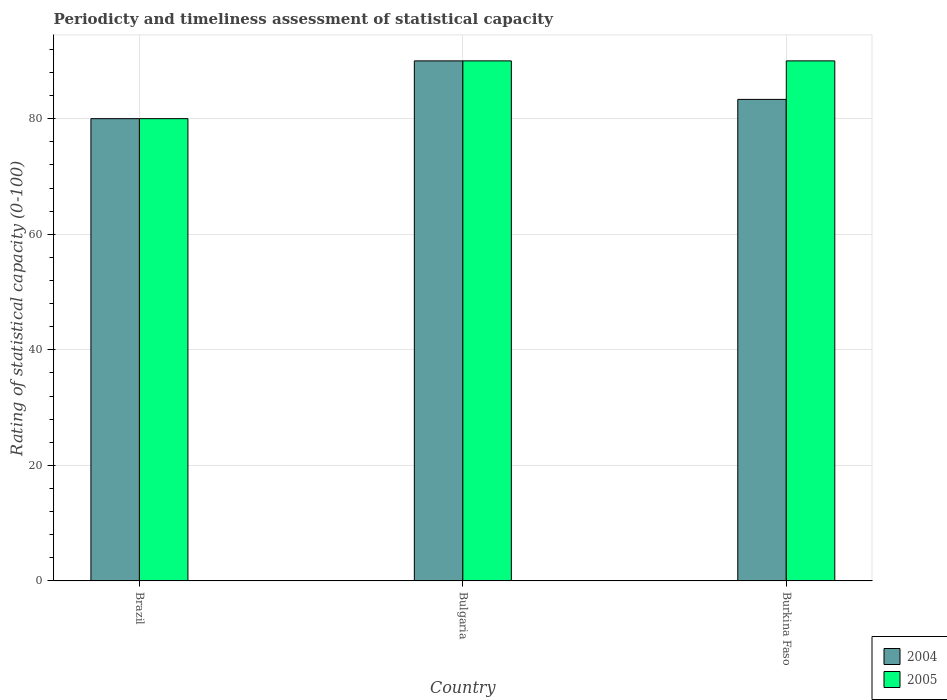How many different coloured bars are there?
Offer a terse response. 2. Are the number of bars on each tick of the X-axis equal?
Provide a short and direct response. Yes. How many bars are there on the 1st tick from the left?
Provide a succinct answer. 2. How many bars are there on the 3rd tick from the right?
Ensure brevity in your answer.  2. What is the label of the 2nd group of bars from the left?
Ensure brevity in your answer.  Bulgaria. In how many cases, is the number of bars for a given country not equal to the number of legend labels?
Provide a short and direct response. 0. In which country was the rating of statistical capacity in 2004 maximum?
Your response must be concise. Bulgaria. In which country was the rating of statistical capacity in 2005 minimum?
Provide a short and direct response. Brazil. What is the total rating of statistical capacity in 2005 in the graph?
Your response must be concise. 260. What is the difference between the rating of statistical capacity in 2004 in Burkina Faso and the rating of statistical capacity in 2005 in Bulgaria?
Ensure brevity in your answer.  -6.67. What is the average rating of statistical capacity in 2005 per country?
Keep it short and to the point. 86.67. What is the difference between the rating of statistical capacity of/in 2004 and rating of statistical capacity of/in 2005 in Burkina Faso?
Keep it short and to the point. -6.67. What is the ratio of the rating of statistical capacity in 2004 in Brazil to that in Bulgaria?
Keep it short and to the point. 0.89. Is the rating of statistical capacity in 2004 in Bulgaria less than that in Burkina Faso?
Make the answer very short. No. Is the difference between the rating of statistical capacity in 2004 in Bulgaria and Burkina Faso greater than the difference between the rating of statistical capacity in 2005 in Bulgaria and Burkina Faso?
Your response must be concise. Yes. What is the difference between the highest and the lowest rating of statistical capacity in 2004?
Your answer should be compact. 10. Is the sum of the rating of statistical capacity in 2004 in Bulgaria and Burkina Faso greater than the maximum rating of statistical capacity in 2005 across all countries?
Make the answer very short. Yes. What does the 2nd bar from the left in Bulgaria represents?
Your answer should be very brief. 2005. How many bars are there?
Offer a terse response. 6. What is the difference between two consecutive major ticks on the Y-axis?
Your answer should be compact. 20. Are the values on the major ticks of Y-axis written in scientific E-notation?
Ensure brevity in your answer.  No. Does the graph contain any zero values?
Offer a very short reply. No. Does the graph contain grids?
Your answer should be very brief. Yes. How many legend labels are there?
Your answer should be compact. 2. What is the title of the graph?
Ensure brevity in your answer.  Periodicty and timeliness assessment of statistical capacity. What is the label or title of the X-axis?
Offer a very short reply. Country. What is the label or title of the Y-axis?
Provide a short and direct response. Rating of statistical capacity (0-100). What is the Rating of statistical capacity (0-100) of 2005 in Brazil?
Give a very brief answer. 80. What is the Rating of statistical capacity (0-100) of 2004 in Bulgaria?
Your response must be concise. 90. What is the Rating of statistical capacity (0-100) of 2004 in Burkina Faso?
Keep it short and to the point. 83.33. Across all countries, what is the maximum Rating of statistical capacity (0-100) in 2004?
Offer a very short reply. 90. Across all countries, what is the minimum Rating of statistical capacity (0-100) in 2004?
Ensure brevity in your answer.  80. What is the total Rating of statistical capacity (0-100) of 2004 in the graph?
Keep it short and to the point. 253.33. What is the total Rating of statistical capacity (0-100) in 2005 in the graph?
Your answer should be compact. 260. What is the difference between the Rating of statistical capacity (0-100) in 2005 in Bulgaria and that in Burkina Faso?
Provide a short and direct response. 0. What is the difference between the Rating of statistical capacity (0-100) of 2004 in Brazil and the Rating of statistical capacity (0-100) of 2005 in Bulgaria?
Your response must be concise. -10. What is the difference between the Rating of statistical capacity (0-100) of 2004 in Bulgaria and the Rating of statistical capacity (0-100) of 2005 in Burkina Faso?
Provide a short and direct response. 0. What is the average Rating of statistical capacity (0-100) in 2004 per country?
Offer a terse response. 84.44. What is the average Rating of statistical capacity (0-100) in 2005 per country?
Your response must be concise. 86.67. What is the difference between the Rating of statistical capacity (0-100) of 2004 and Rating of statistical capacity (0-100) of 2005 in Bulgaria?
Offer a terse response. 0. What is the difference between the Rating of statistical capacity (0-100) in 2004 and Rating of statistical capacity (0-100) in 2005 in Burkina Faso?
Your answer should be very brief. -6.67. What is the ratio of the Rating of statistical capacity (0-100) of 2004 in Brazil to that in Bulgaria?
Give a very brief answer. 0.89. What is the ratio of the Rating of statistical capacity (0-100) in 2005 in Brazil to that in Bulgaria?
Provide a short and direct response. 0.89. What is the ratio of the Rating of statistical capacity (0-100) of 2004 in Brazil to that in Burkina Faso?
Offer a terse response. 0.96. What is the ratio of the Rating of statistical capacity (0-100) in 2005 in Brazil to that in Burkina Faso?
Ensure brevity in your answer.  0.89. What is the ratio of the Rating of statistical capacity (0-100) in 2004 in Bulgaria to that in Burkina Faso?
Offer a terse response. 1.08. What is the ratio of the Rating of statistical capacity (0-100) in 2005 in Bulgaria to that in Burkina Faso?
Ensure brevity in your answer.  1. What is the difference between the highest and the second highest Rating of statistical capacity (0-100) of 2004?
Make the answer very short. 6.67. What is the difference between the highest and the second highest Rating of statistical capacity (0-100) of 2005?
Ensure brevity in your answer.  0. What is the difference between the highest and the lowest Rating of statistical capacity (0-100) in 2004?
Ensure brevity in your answer.  10. 